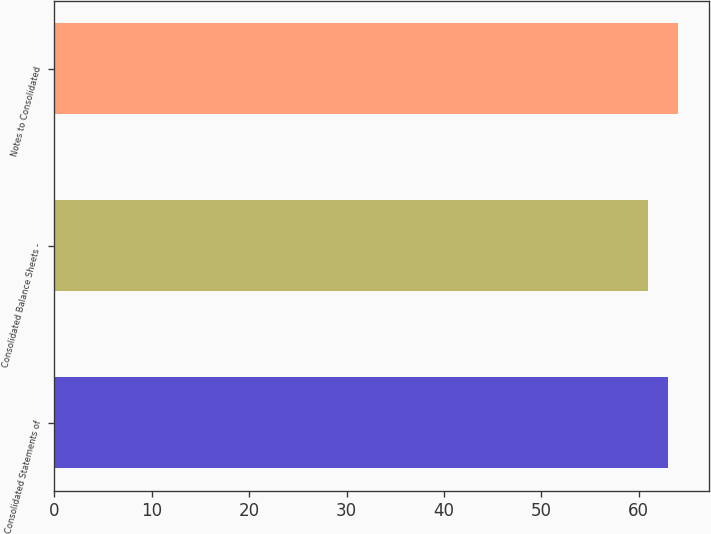Convert chart to OTSL. <chart><loc_0><loc_0><loc_500><loc_500><bar_chart><fcel>Consolidated Statements of<fcel>Consolidated Balance Sheets -<fcel>Notes to Consolidated<nl><fcel>63<fcel>61<fcel>64<nl></chart> 